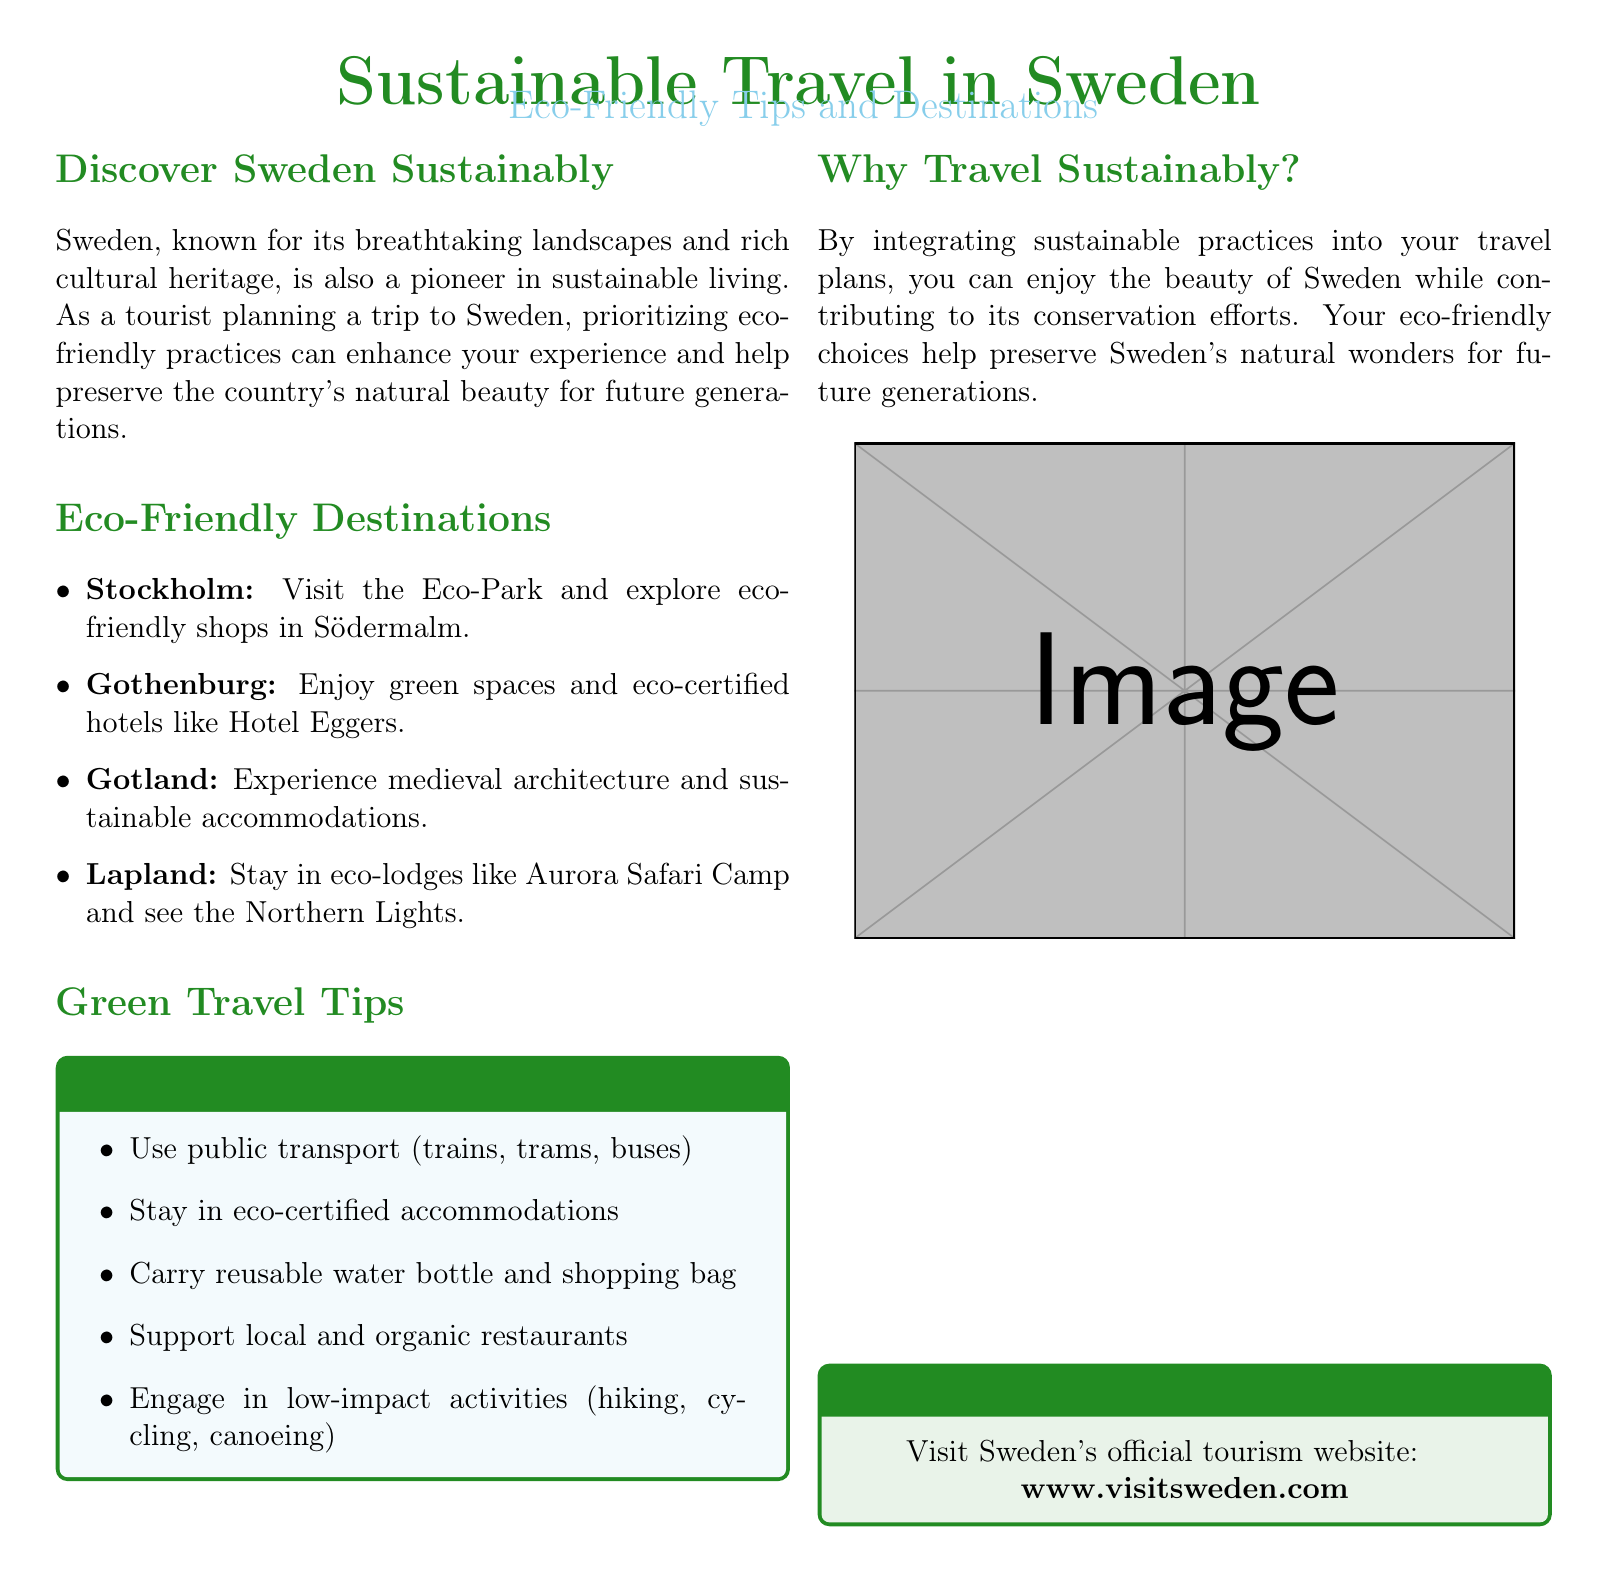What is the title of the document? The title of the document is prominently displayed at the top.
Answer: Sustainable Travel in Sweden What type of travel tips are featured? The document specifically focuses on sustainable practices for travelers.
Answer: Eco-Friendly Tips Which city is mentioned for its Eco-Park? The city noted for having an Eco-Park is listed under eco-friendly destinations.
Answer: Stockholm Name one eco-certified hotel in Gothenburg. The document provides an example of an eco-certified hotel in Gothenburg.
Answer: Hotel Eggers What activity is suggested for low-impact engagement? The document lists several low-impact activities to partake in.
Answer: Hiking Why travel sustainably according to the document? The document describes the benefits of integrating sustainable practices into travel plans.
Answer: Conservation What is the official tourism website for more information? The website is referenced in a dedicated information box in the document.
Answer: www.visitsweden.com 